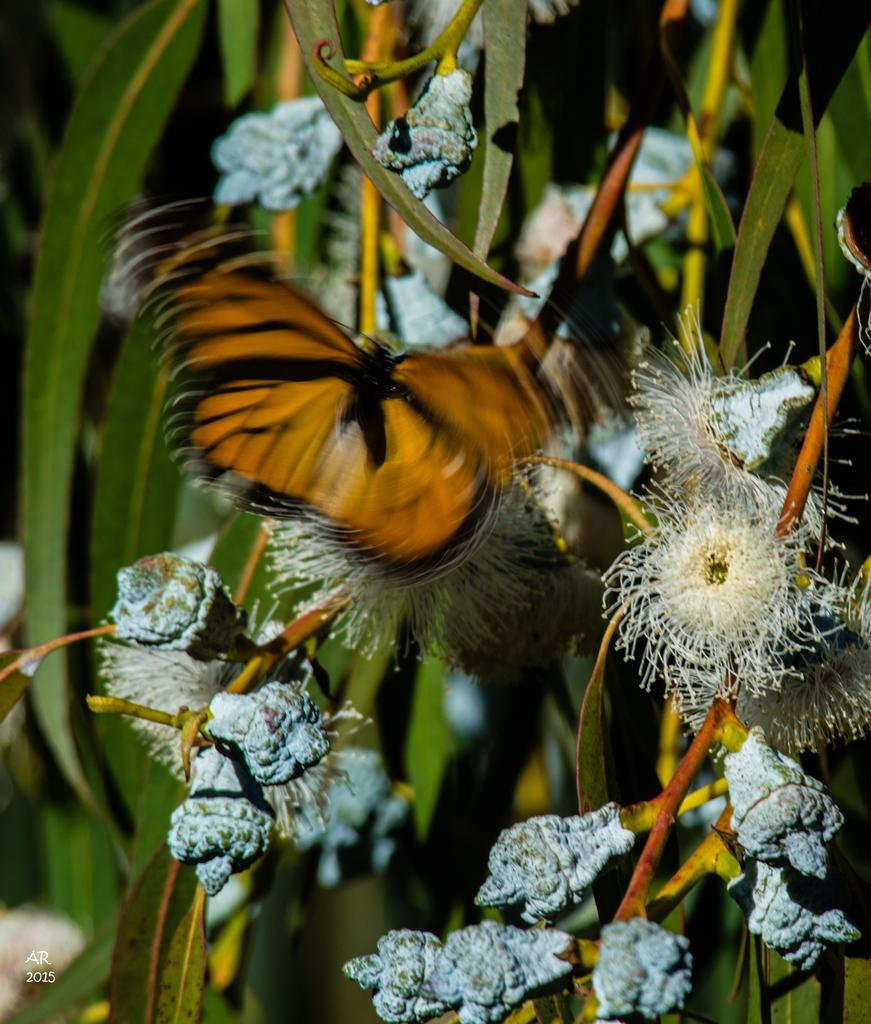What is the main subject of the image? There is a butterfly in the image. What is the butterfly doing in the image? The butterfly is flying. What can be seen in the background of the image? There are plants and flowers in the background of the image. How is the background of the image depicted? The background of the image is blurred. What type of vest is the butterfly wearing in the image? There is no vest present in the image, as butterflies do not wear clothing. 